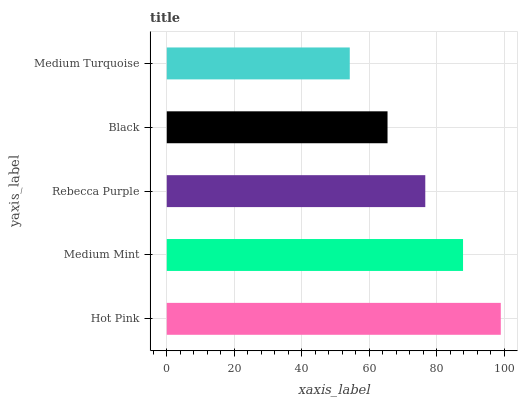Is Medium Turquoise the minimum?
Answer yes or no. Yes. Is Hot Pink the maximum?
Answer yes or no. Yes. Is Medium Mint the minimum?
Answer yes or no. No. Is Medium Mint the maximum?
Answer yes or no. No. Is Hot Pink greater than Medium Mint?
Answer yes or no. Yes. Is Medium Mint less than Hot Pink?
Answer yes or no. Yes. Is Medium Mint greater than Hot Pink?
Answer yes or no. No. Is Hot Pink less than Medium Mint?
Answer yes or no. No. Is Rebecca Purple the high median?
Answer yes or no. Yes. Is Rebecca Purple the low median?
Answer yes or no. Yes. Is Medium Mint the high median?
Answer yes or no. No. Is Medium Turquoise the low median?
Answer yes or no. No. 